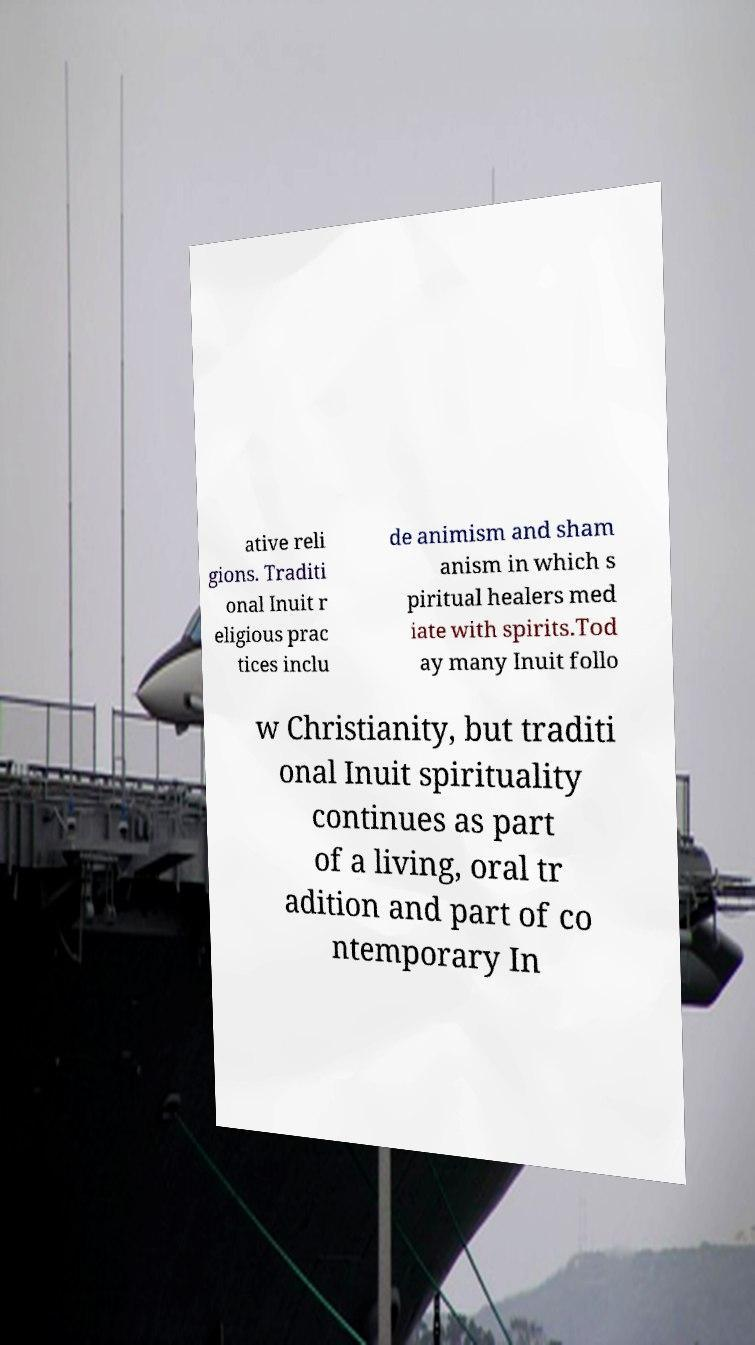What messages or text are displayed in this image? I need them in a readable, typed format. ative reli gions. Traditi onal Inuit r eligious prac tices inclu de animism and sham anism in which s piritual healers med iate with spirits.Tod ay many Inuit follo w Christianity, but traditi onal Inuit spirituality continues as part of a living, oral tr adition and part of co ntemporary In 